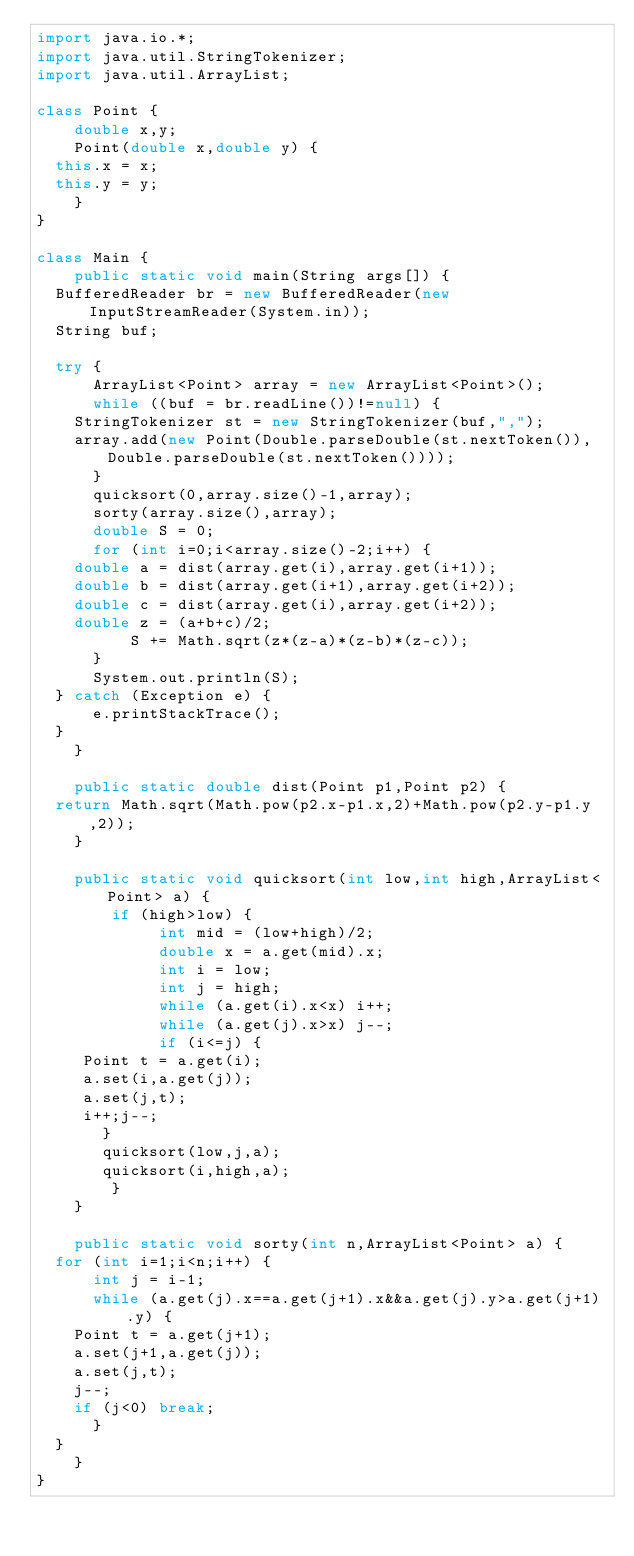Convert code to text. <code><loc_0><loc_0><loc_500><loc_500><_Java_>import java.io.*;
import java.util.StringTokenizer;
import java.util.ArrayList;

class Point {
    double x,y;
    Point(double x,double y) {
	this.x = x;
	this.y = y;
    }
}

class Main {
    public static void main(String args[]) {
	BufferedReader br = new BufferedReader(new InputStreamReader(System.in));
	String buf;

	try {
	    ArrayList<Point> array = new ArrayList<Point>();
	    while ((buf = br.readLine())!=null) {
		StringTokenizer st = new StringTokenizer(buf,",");
		array.add(new Point(Double.parseDouble(st.nextToken()),Double.parseDouble(st.nextToken())));
	    }
	    quicksort(0,array.size()-1,array);
	    sorty(array.size(),array);
	    double S = 0;
	    for (int i=0;i<array.size()-2;i++) {
		double a = dist(array.get(i),array.get(i+1));
		double b = dist(array.get(i+1),array.get(i+2));
		double c = dist(array.get(i),array.get(i+2));
		double z = (a+b+c)/2;
	        S += Math.sqrt(z*(z-a)*(z-b)*(z-c));
	    }
	    System.out.println(S);
	} catch (Exception e) {
	    e.printStackTrace();
	}
    }

    public static double dist(Point p1,Point p2) {
	return Math.sqrt(Math.pow(p2.x-p1.x,2)+Math.pow(p2.y-p1.y,2));
    }

    public static void quicksort(int low,int high,ArrayList<Point> a) {
       	if (high>low) {
       	     int mid = (low+high)/2;
       	     double x = a.get(mid).x;
       	     int i = low;
       	     int j = high;
       	     while (a.get(i).x<x) i++;
       	     while (a.get(j).x>x) j--;
       	     if (i<=j) {
		 Point t = a.get(i);
		 a.set(i,a.get(j));
		 a.set(j,t);
		 i++;j--;
	     }
	     quicksort(low,j,a);
	     quicksort(i,high,a);
       	}
    }

    public static void sorty(int n,ArrayList<Point> a) {
	for (int i=1;i<n;i++) {
	    int j = i-1;
	    while (a.get(j).x==a.get(j+1).x&&a.get(j).y>a.get(j+1).y) {
		Point t = a.get(j+1);
		a.set(j+1,a.get(j));
		a.set(j,t);
		j--;
		if (j<0) break;
	    }
	}
    }
}</code> 